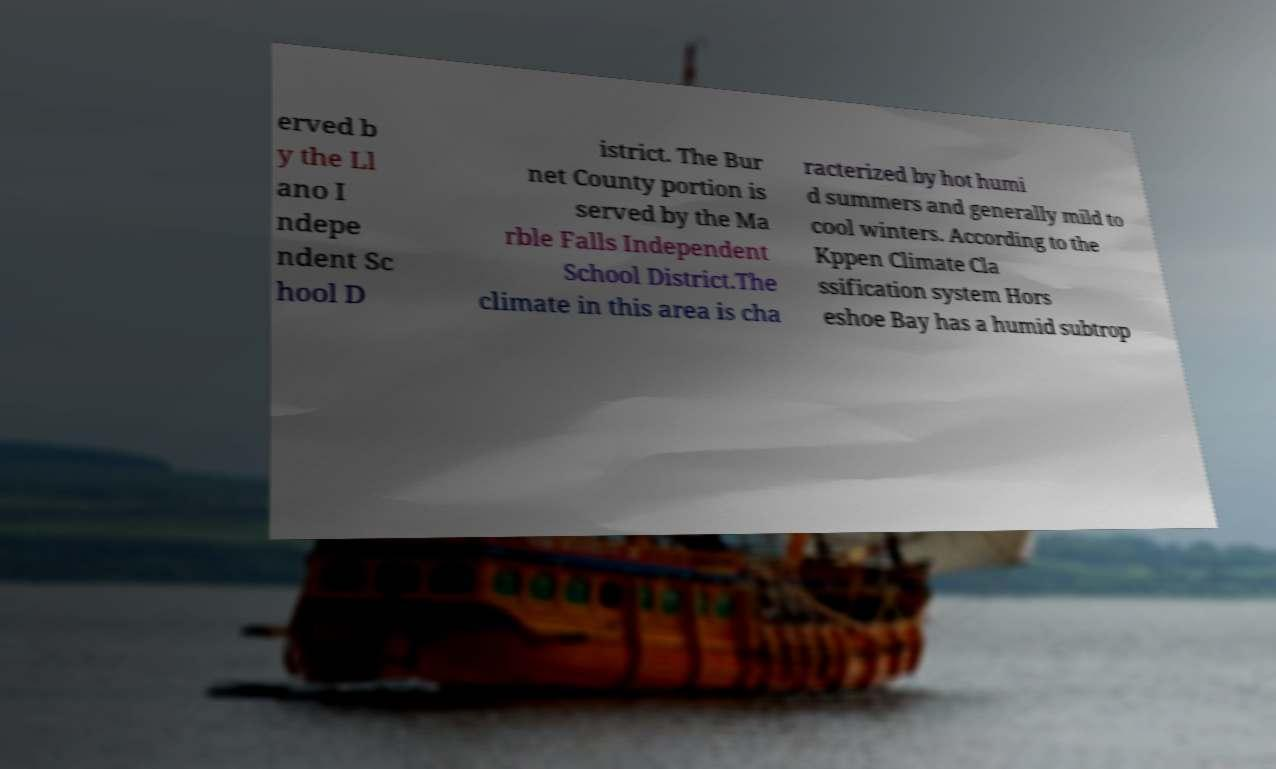Can you accurately transcribe the text from the provided image for me? erved b y the Ll ano I ndepe ndent Sc hool D istrict. The Bur net County portion is served by the Ma rble Falls Independent School District.The climate in this area is cha racterized by hot humi d summers and generally mild to cool winters. According to the Kppen Climate Cla ssification system Hors eshoe Bay has a humid subtrop 